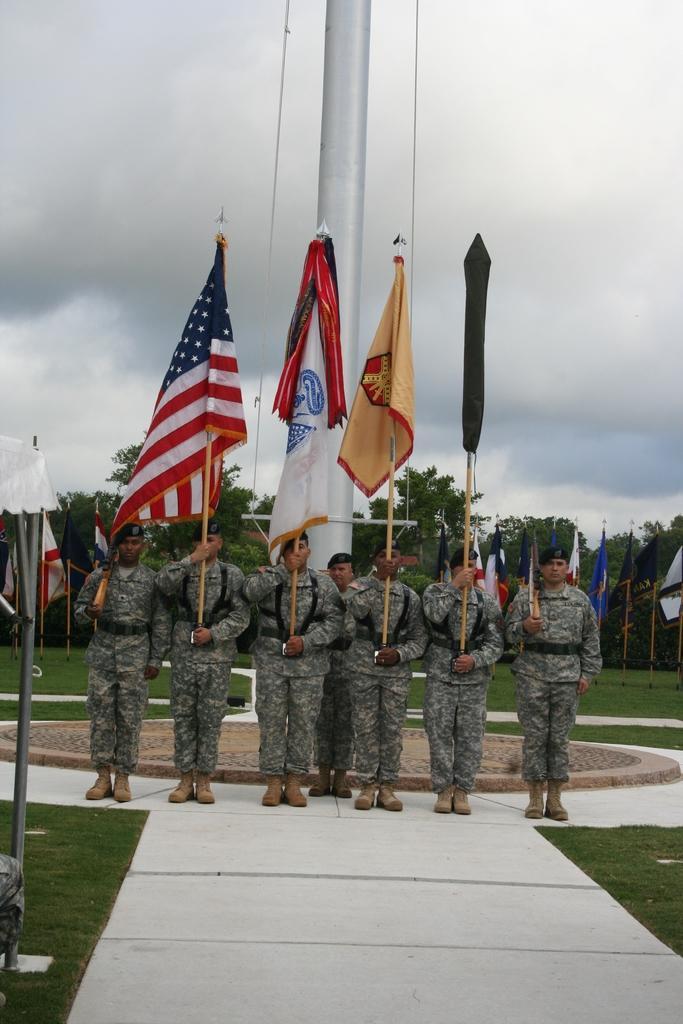Describe this image in one or two sentences. As we can see in the image in the front there are few people wearing army dresses and holding flags. There is grass and trees. At the top there is sky and clouds. 